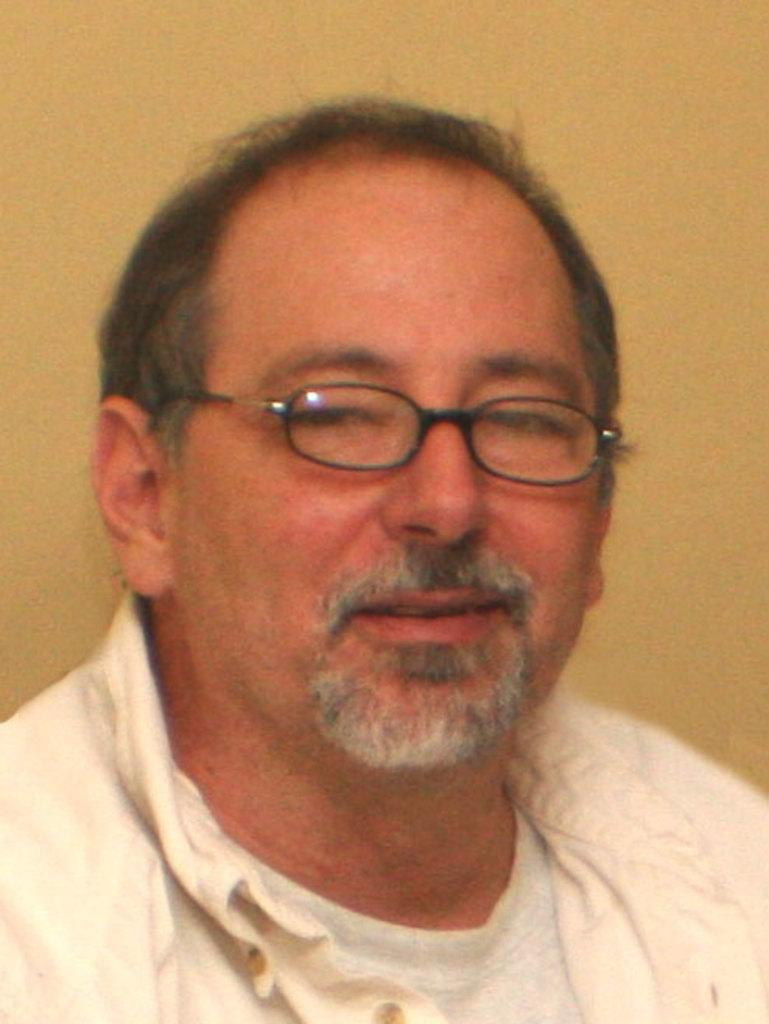What is the main subject of the picture? The main subject of the picture is a man. What is the man's facial expression in the image? The man is smiling in the image. What type of eyewear is the man wearing? The man is wearing black-colored spectacles. What color is the jacket the man is wearing? The man is wearing a white jacket. What type of shirt is the man wearing underneath the jacket? The man is wearing a white shirt underneath the jacket. How many units of regret can be seen on the man's face in the image? There is no mention of regret or units of regret in the image; the man is simply smiling. 